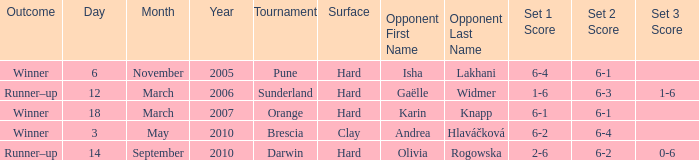What kind of surface was the Tournament at Sunderland played on? Hard. 